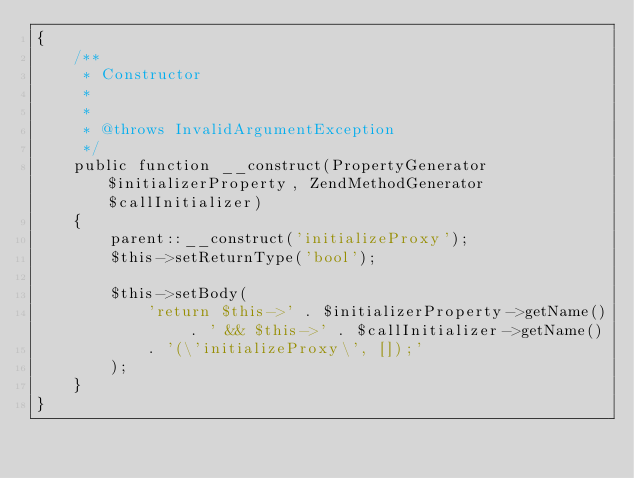Convert code to text. <code><loc_0><loc_0><loc_500><loc_500><_PHP_>{
    /**
     * Constructor
     *
     *
     * @throws InvalidArgumentException
     */
    public function __construct(PropertyGenerator $initializerProperty, ZendMethodGenerator $callInitializer)
    {
        parent::__construct('initializeProxy');
        $this->setReturnType('bool');

        $this->setBody(
            'return $this->' . $initializerProperty->getName() . ' && $this->' . $callInitializer->getName()
            . '(\'initializeProxy\', []);'
        );
    }
}
</code> 